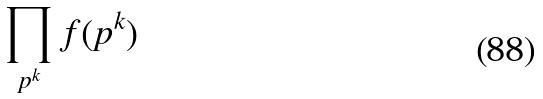<formula> <loc_0><loc_0><loc_500><loc_500>\prod _ { p ^ { k } } f ( p ^ { k } )</formula> 